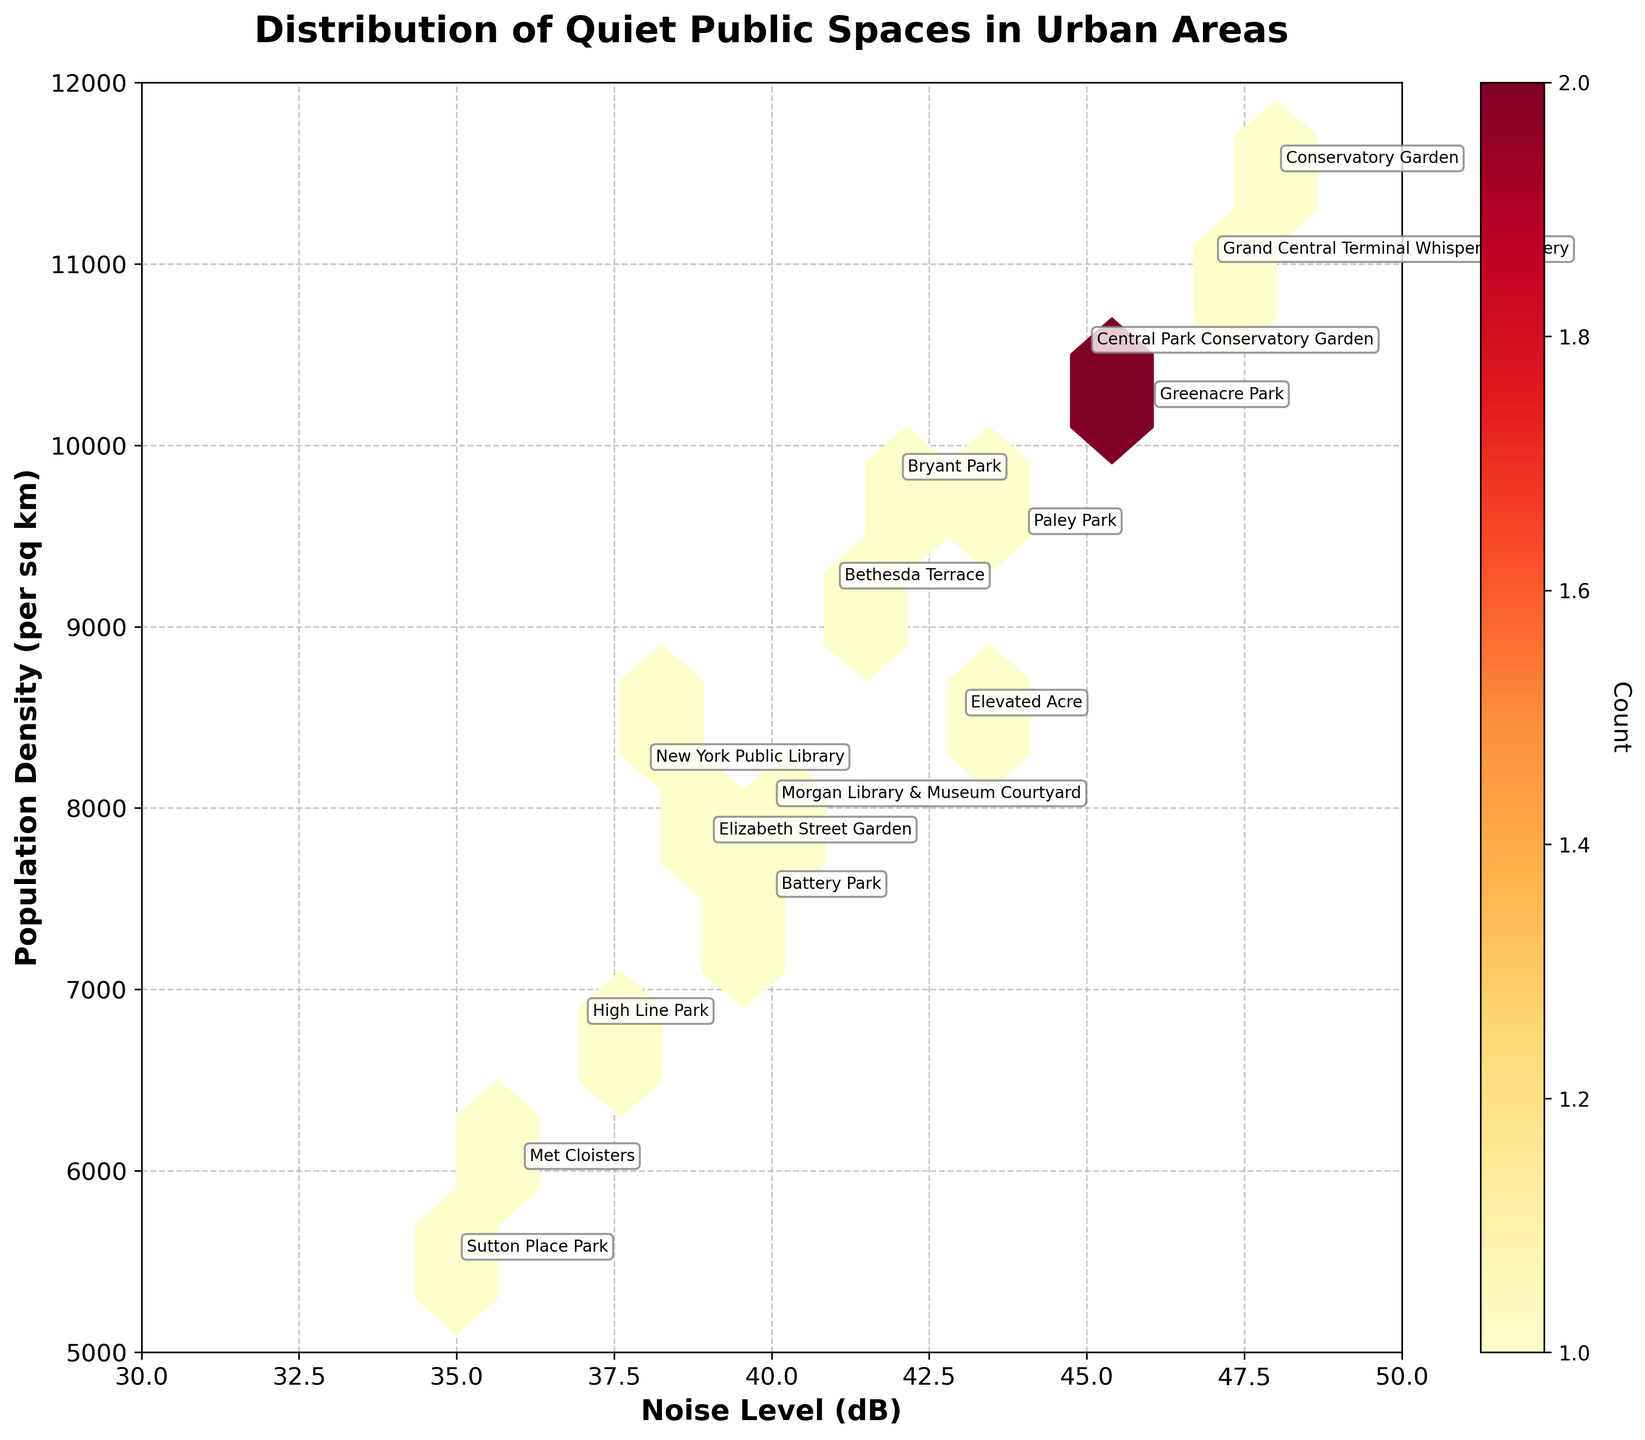What's the title of the plot? The title of the plot is positioned at the top and is styled in bold. It reads "Distribution of Quiet Public Spaces in Urban Areas".
Answer: Distribution of Quiet Public Spaces in Urban Areas What are the labels of the x-axis and y-axis? The x-axis label is "Noise Level (dB)" and the y-axis label is "Population Density (per sq km)".
Answer: Noise Level (dB) and Population Density (per sq km) How many hexagons have a count of at least 1? The plot aggregates the data into hexagons. Each hexagon must be scrutinized to manually count the ones with a visible count starting from 1. Observing the plot, we notice about 15 hexagons.
Answer: 15 What is the location with the highest noise level and its corresponding population density? By examining the annotated data points, the location with the highest noise level of 48 dB is the Conservatory Garden with a corresponding population density of 11500 per sq km.
Answer: Conservatory Garden, 11500 per sq km What is the range of the noise level visible in the plot? The x-axis displays the range of noise levels from 30 dB to 50 dB.
Answer: 30 dB to 50 dB How does the population density of "Met Cloisters" compare to "Bryant Park"? Look at the annotated points for Met Cloisters and Bryant Park. The population density for Met Cloisters is 6000 per sq km, whereas for Bryant Park, it is 9800 per sq km. Met Cloisters has a lower population density compared to Bryant Park.
Answer: Met Cloisters: 6000 per sq km, Bryant Park: 9800 per sq km, Met Cloisters is lower Which location has the lowest noise level and what is its noise level? Examining the annotated points, the location with the lowest noise level is the Met Cloisters with a noise level of 36 dB.
Answer: Met Cloisters, 36 dB What is the color used for the count in the hexbin plot? The color map used in the hexbin plot ranges from yellow to red, following the YlOrRd color scheme.
Answer: Yellow to red Which location is labeled at the highest population density and what is its noise level? By looking at the labels, the location at the highest population density is the Conservatory Garden with a noise level of 48 dB.
Answer: Conservatory Garden, 48 dB Are there any hexagons that represent more than one location? Some hexagons could possibly represent the aggregated counts of locations that overlap in noise level and population density ranges. This is evident since each hexagon isn't necessarily tied to a single location but a range.
Answer: Yes 